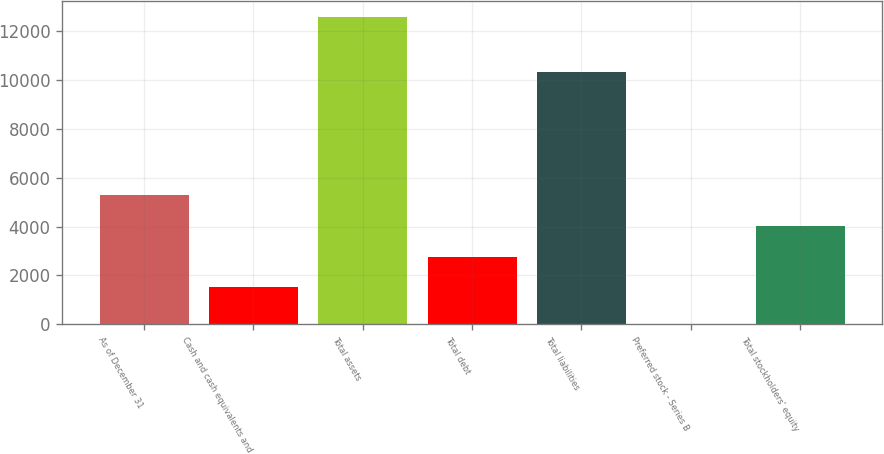Convert chart. <chart><loc_0><loc_0><loc_500><loc_500><bar_chart><fcel>As of December 31<fcel>Cash and cash equivalents and<fcel>Total assets<fcel>Total debt<fcel>Total liabilities<fcel>Preferred stock - Series B<fcel>Total stockholders' equity<nl><fcel>5284.9<fcel>1509.7<fcel>12585.1<fcel>2768.1<fcel>10331.4<fcel>1.07<fcel>4026.5<nl></chart> 